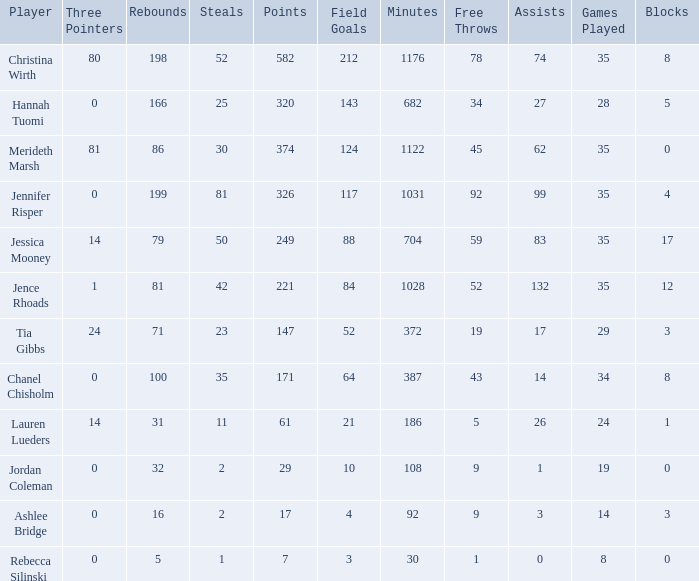Would you mind parsing the complete table? {'header': ['Player', 'Three Pointers', 'Rebounds', 'Steals', 'Points', 'Field Goals', 'Minutes', 'Free Throws', 'Assists', 'Games Played', 'Blocks'], 'rows': [['Christina Wirth', '80', '198', '52', '582', '212', '1176', '78', '74', '35', '8'], ['Hannah Tuomi', '0', '166', '25', '320', '143', '682', '34', '27', '28', '5'], ['Merideth Marsh', '81', '86', '30', '374', '124', '1122', '45', '62', '35', '0'], ['Jennifer Risper', '0', '199', '81', '326', '117', '1031', '92', '99', '35', '4'], ['Jessica Mooney', '14', '79', '50', '249', '88', '704', '59', '83', '35', '17'], ['Jence Rhoads', '1', '81', '42', '221', '84', '1028', '52', '132', '35', '12'], ['Tia Gibbs', '24', '71', '23', '147', '52', '372', '19', '17', '29', '3'], ['Chanel Chisholm', '0', '100', '35', '171', '64', '387', '43', '14', '34', '8'], ['Lauren Lueders', '14', '31', '11', '61', '21', '186', '5', '26', '24', '1'], ['Jordan Coleman', '0', '32', '2', '29', '10', '108', '9', '1', '19', '0'], ['Ashlee Bridge', '0', '16', '2', '17', '4', '92', '9', '3', '14', '3'], ['Rebecca Silinski', '0', '5', '1', '7', '3', '30', '1', '0', '8', '0']]} How much time, in minutes, did Chanel Chisholm play? 1.0. 